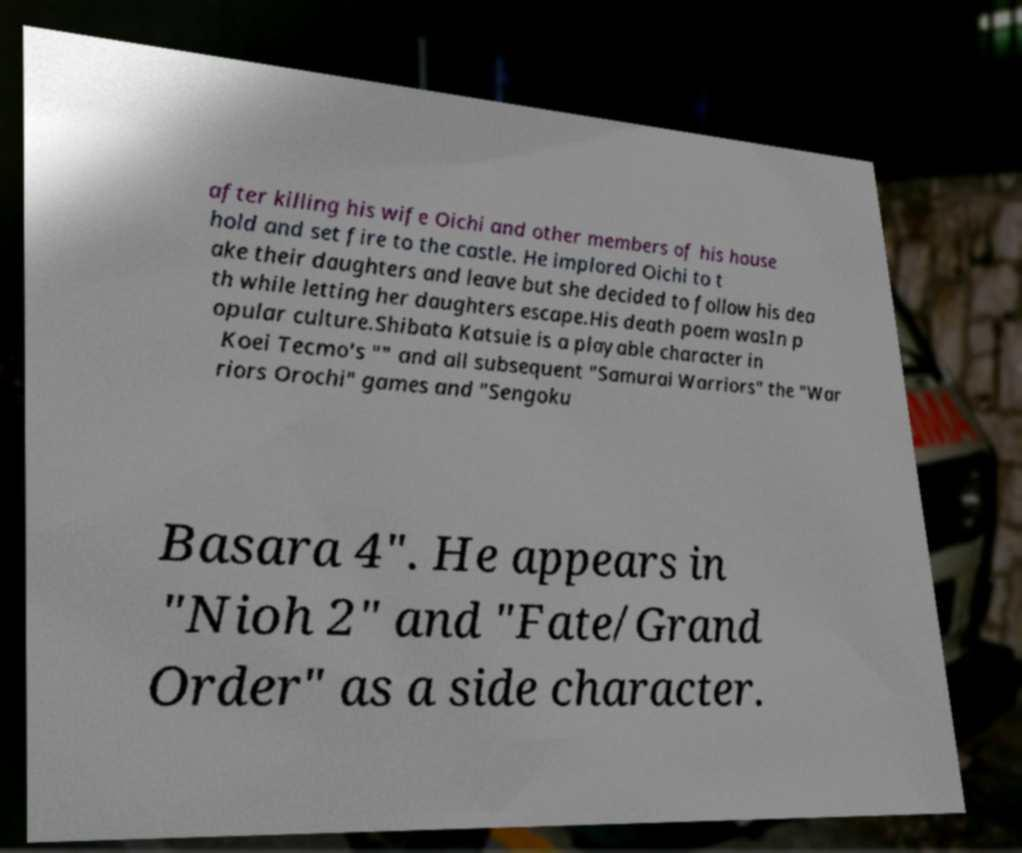I need the written content from this picture converted into text. Can you do that? after killing his wife Oichi and other members of his house hold and set fire to the castle. He implored Oichi to t ake their daughters and leave but she decided to follow his dea th while letting her daughters escape.His death poem wasIn p opular culture.Shibata Katsuie is a playable character in Koei Tecmo's "" and all subsequent "Samurai Warriors" the "War riors Orochi" games and "Sengoku Basara 4". He appears in "Nioh 2" and "Fate/Grand Order" as a side character. 